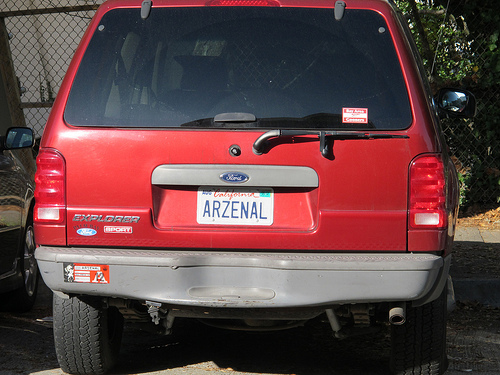<image>
Is the wiper above the sticker? No. The wiper is not positioned above the sticker. The vertical arrangement shows a different relationship. 